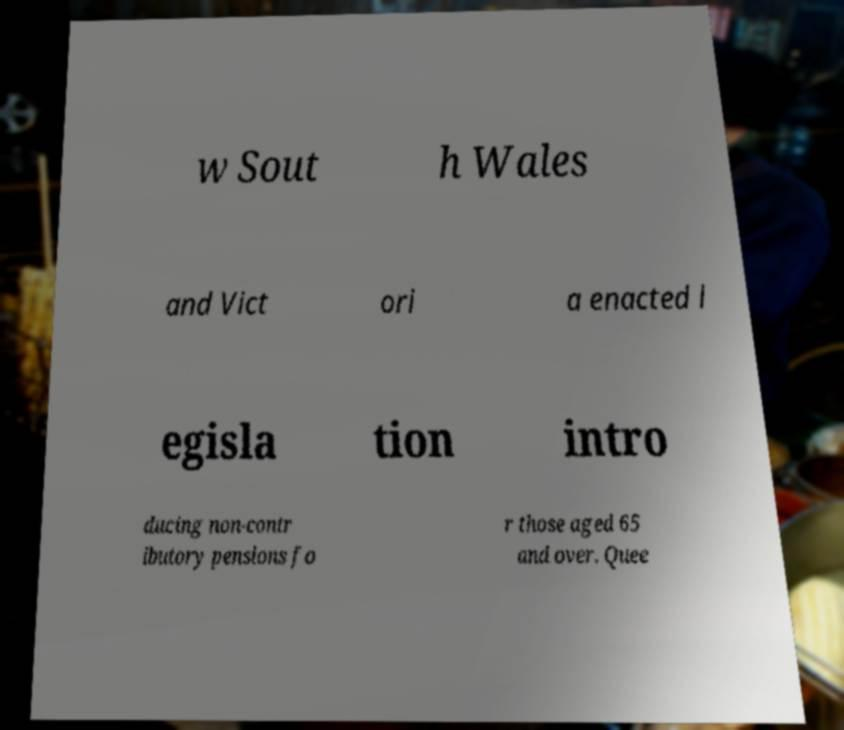Can you accurately transcribe the text from the provided image for me? w Sout h Wales and Vict ori a enacted l egisla tion intro ducing non-contr ibutory pensions fo r those aged 65 and over. Quee 